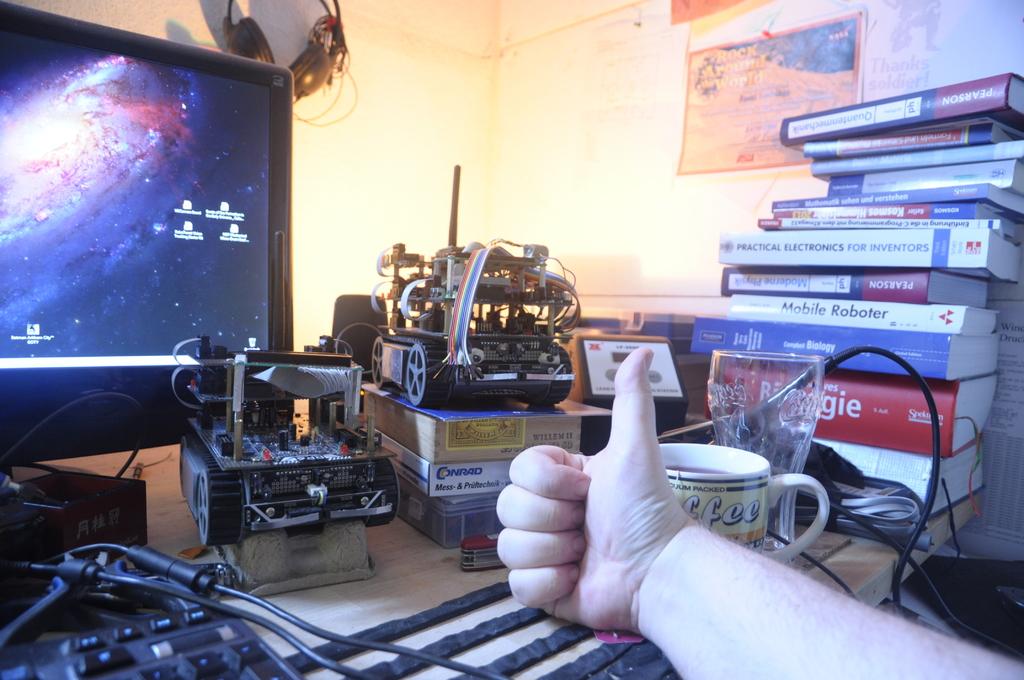What type of electronics is the book about for inventors?
Provide a succinct answer. Practical electronics. 